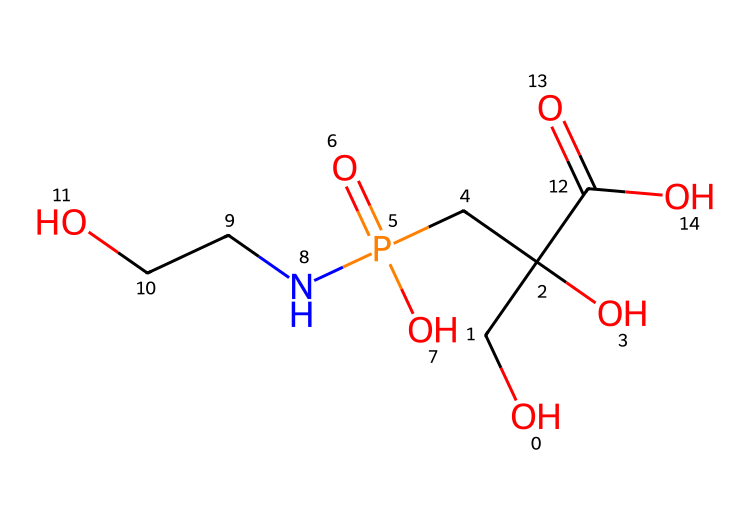How many carbon atoms are in glyphosate? The chemical structure of glyphosate contains a total of 5 carbon atoms. By analyzing the SMILES representation, we identify the "C" symbols which represent carbon atoms.
Answer: 5 What is the functional group represented by "P(=O)(O)" in glyphosate? The notation "P(=O)(O)" indicates the presence of a phosphate group. Phosphorus is bonded to an oxygen double bond (indicated by '=') and two hydroxyl groups (indicated by '(O)'). Therefore, this functional group is a phosphate.
Answer: phosphate What is the total number of nitrogen atoms in the structure? The chemical structure contains 1 nitrogen atom, represented by the "N" in the SMILES notation. Counting the appearances in the sequence reveals there is just one.
Answer: 1 Which part of glyphosate is responsible for its herbicidal activity? The nitrogen atom within the amine functional group contributes to glyphosate’s herbicidal activity by inhibiting a specific enzyme pathway in plants. This is critical to understand glyphosate's mechanism of action.
Answer: nitrogen What type of herbicide is glyphosate classified as? Glyphosate is classified as a non-selective herbicide. This means it can kill a wide range of plants rather than targeting specific species. This classification is derived from its method of action through the inhibition of plant growth pathways.
Answer: non-selective 